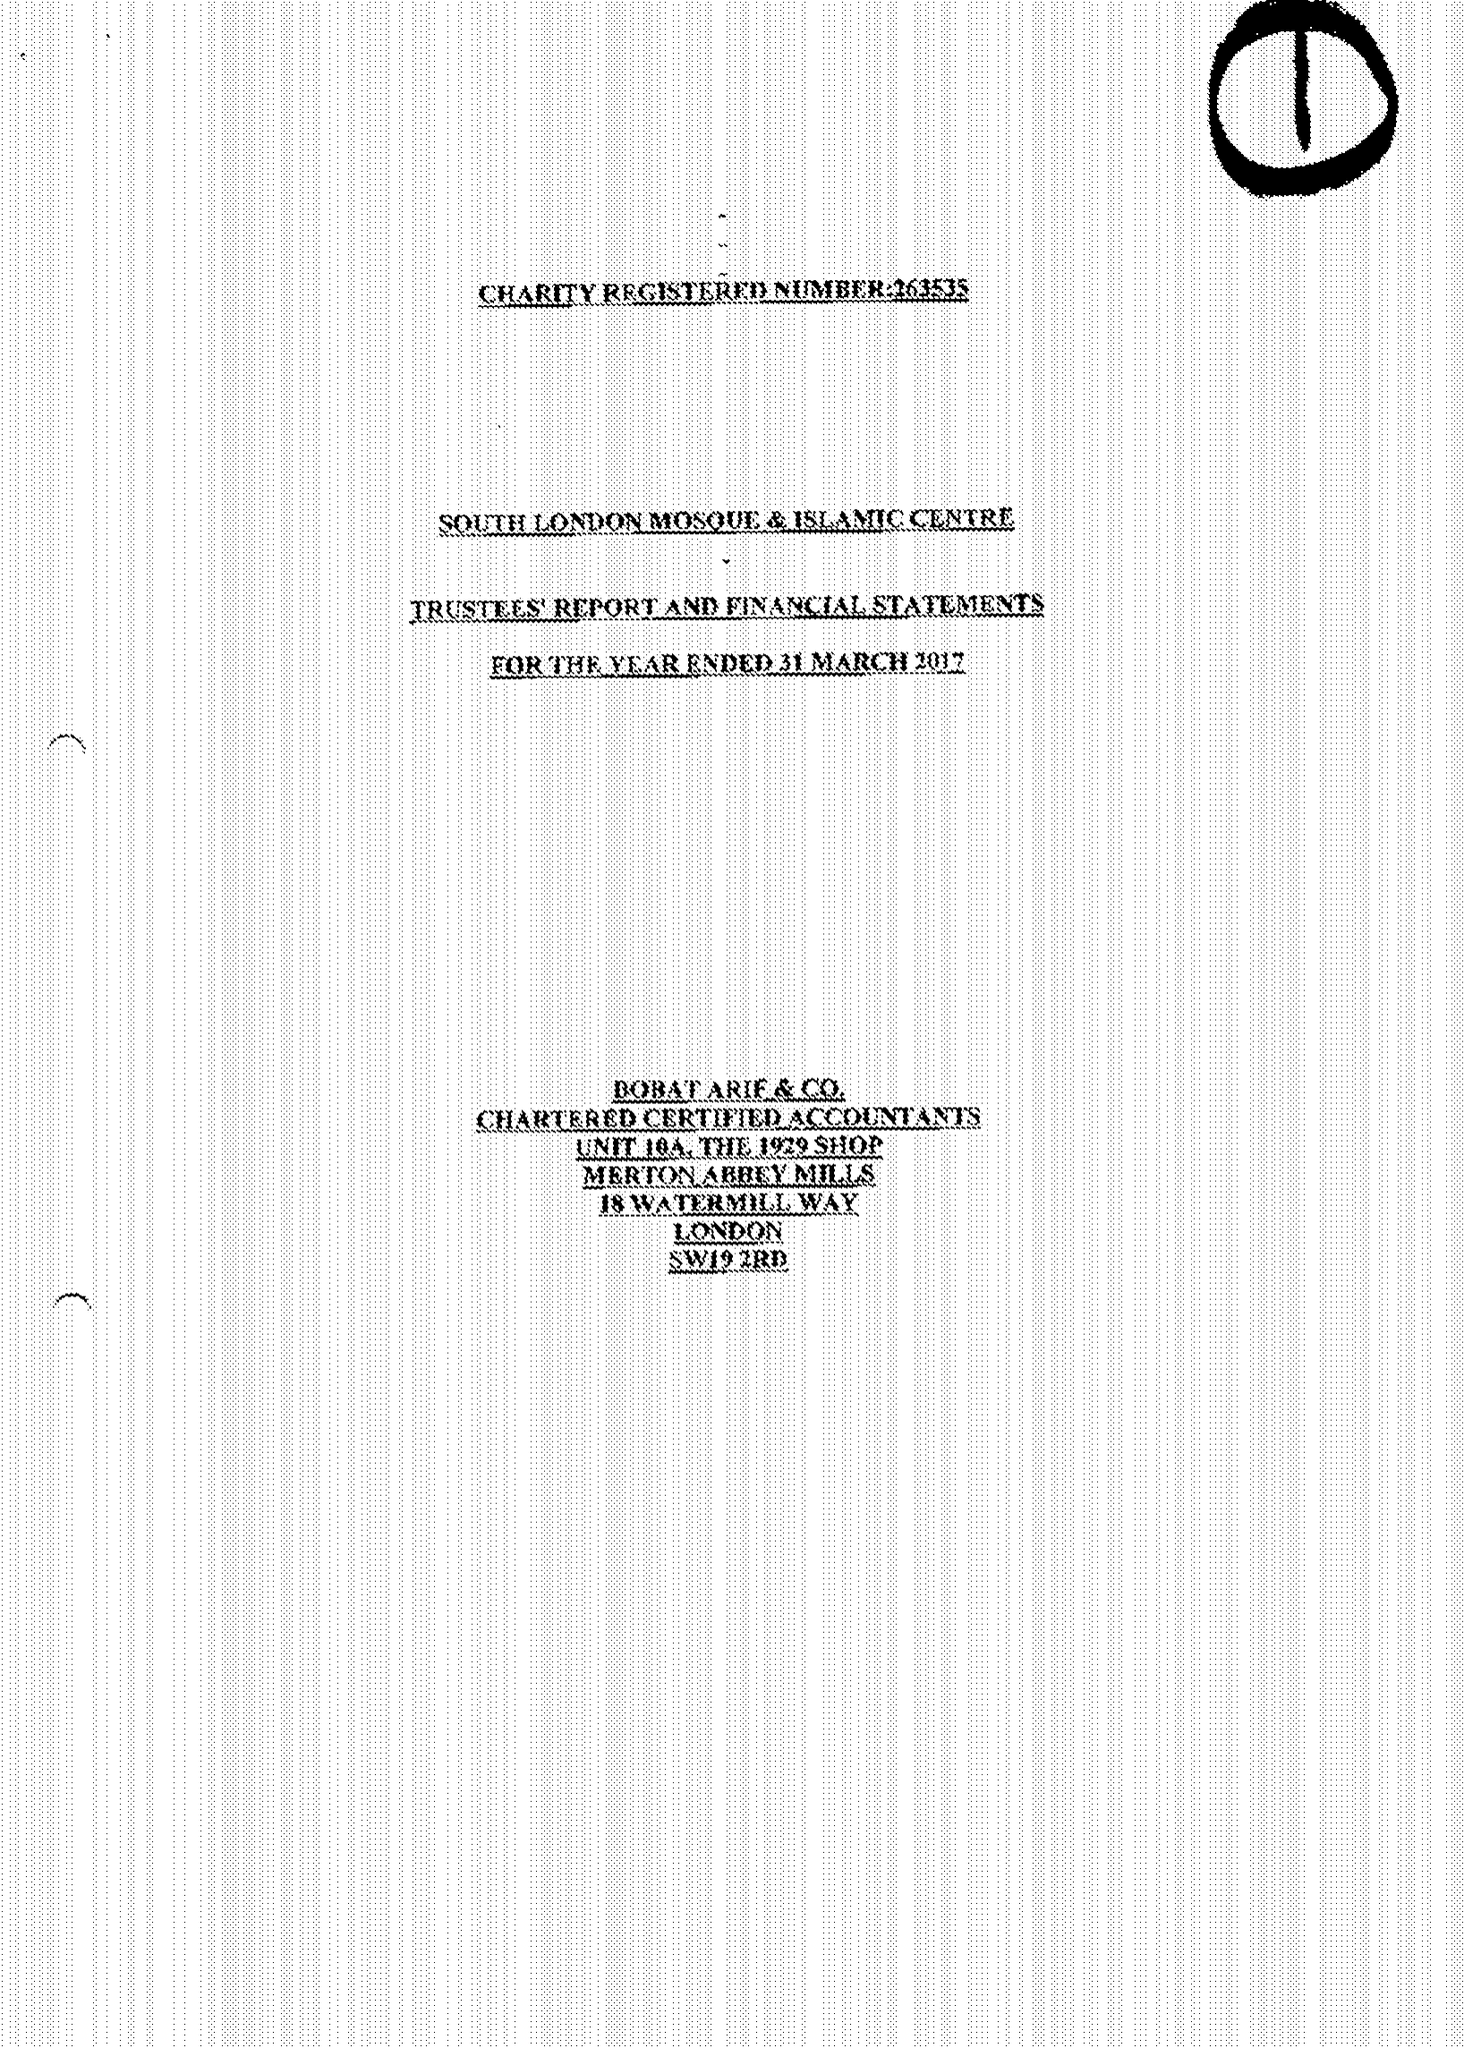What is the value for the report_date?
Answer the question using a single word or phrase. 2017-03-31 